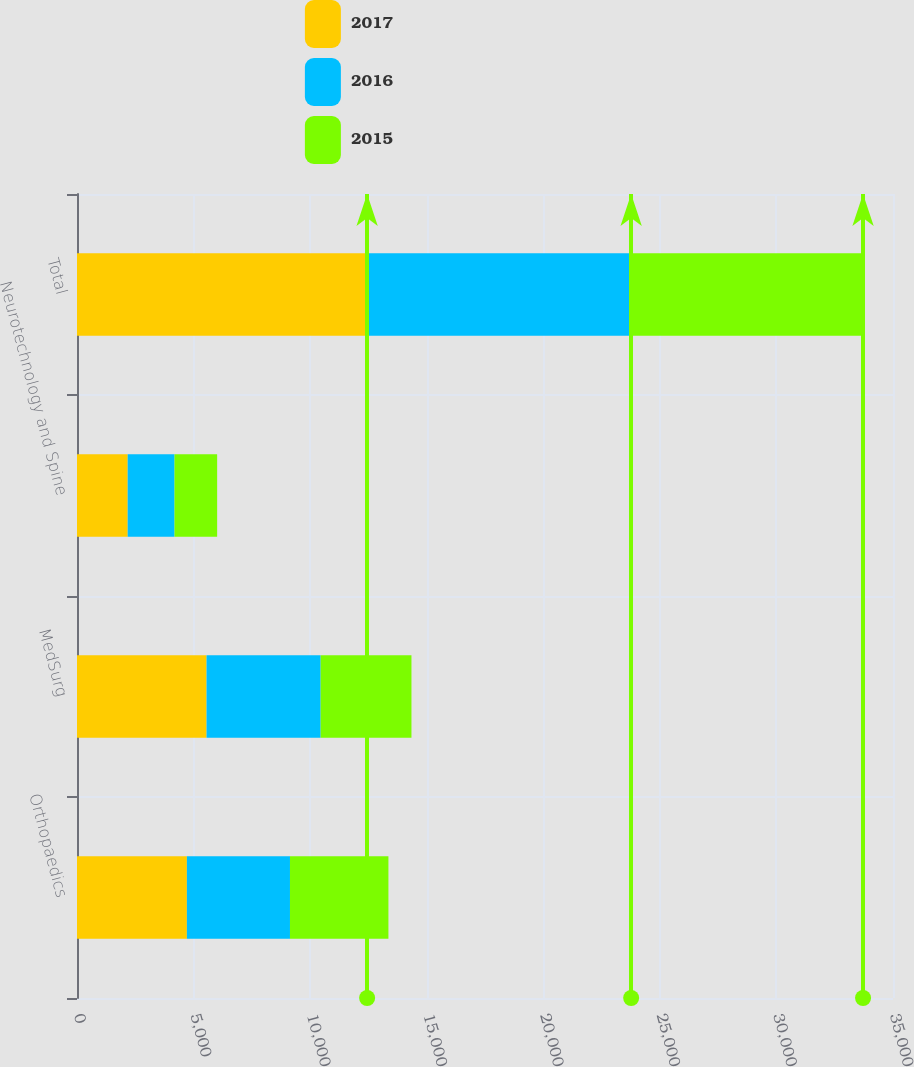Convert chart. <chart><loc_0><loc_0><loc_500><loc_500><stacked_bar_chart><ecel><fcel>Orthopaedics<fcel>MedSurg<fcel>Neurotechnology and Spine<fcel>Total<nl><fcel>2017<fcel>4713<fcel>5557<fcel>2174<fcel>12444<nl><fcel>2016<fcel>4422<fcel>4894<fcel>2009<fcel>11325<nl><fcel>2015<fcel>4223<fcel>3895<fcel>1828<fcel>9946<nl></chart> 